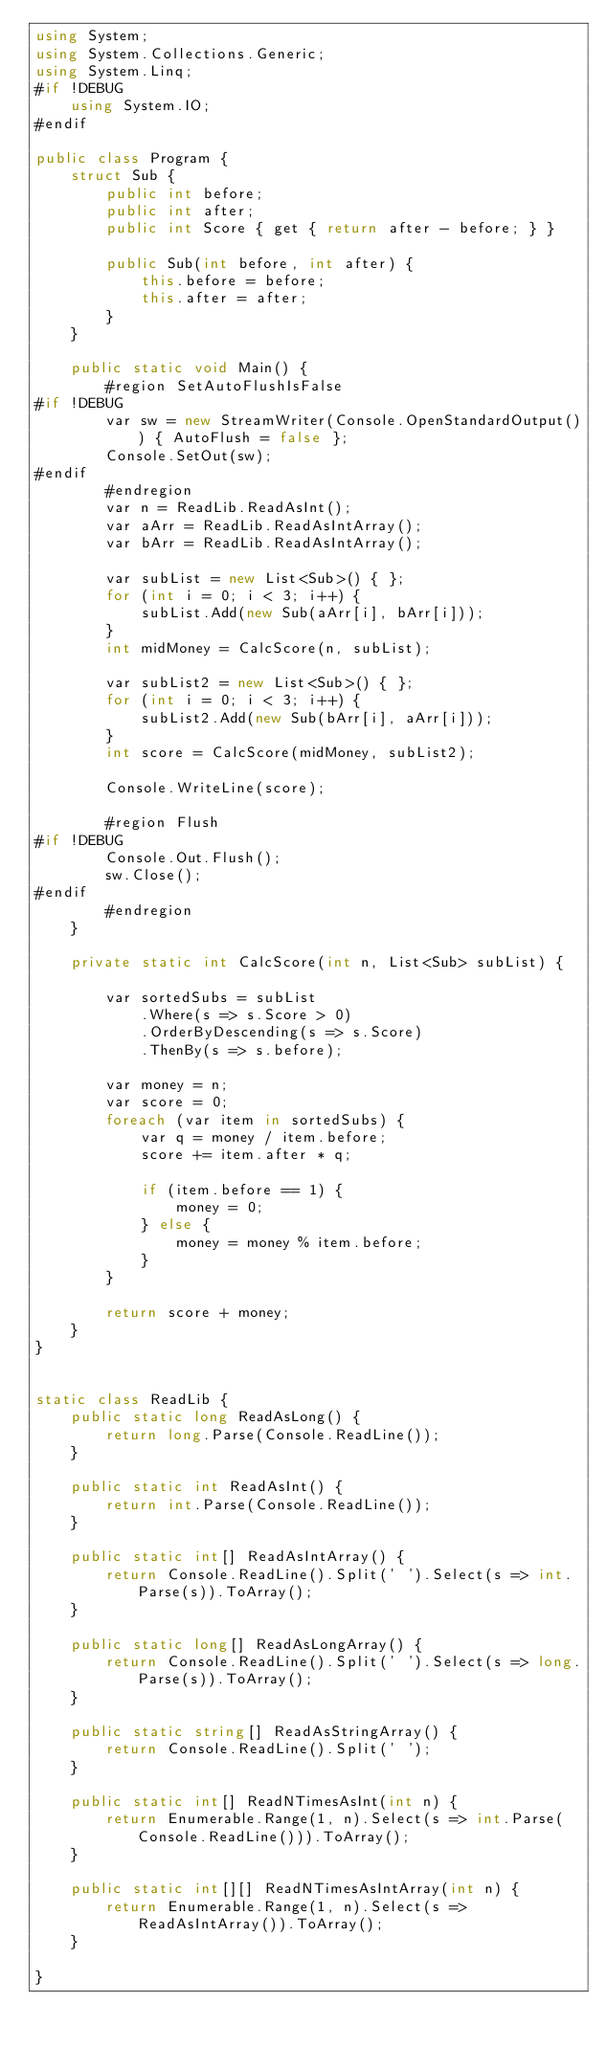<code> <loc_0><loc_0><loc_500><loc_500><_C#_>using System;
using System.Collections.Generic;
using System.Linq;
#if !DEBUG
    using System.IO;
#endif

public class Program {
    struct Sub {
        public int before;
        public int after;
        public int Score { get { return after - before; } }

        public Sub(int before, int after) {
            this.before = before;
            this.after = after;
        }
    }

    public static void Main() {
        #region SetAutoFlushIsFalse
#if !DEBUG
        var sw = new StreamWriter(Console.OpenStandardOutput()) { AutoFlush = false };
        Console.SetOut(sw);
#endif
        #endregion
        var n = ReadLib.ReadAsInt();
        var aArr = ReadLib.ReadAsIntArray();
        var bArr = ReadLib.ReadAsIntArray();

        var subList = new List<Sub>() { };
        for (int i = 0; i < 3; i++) {
            subList.Add(new Sub(aArr[i], bArr[i]));
        }
        int midMoney = CalcScore(n, subList);

        var subList2 = new List<Sub>() { };
        for (int i = 0; i < 3; i++) {
            subList2.Add(new Sub(bArr[i], aArr[i]));
        }
        int score = CalcScore(midMoney, subList2);

        Console.WriteLine(score);

        #region Flush
#if !DEBUG
        Console.Out.Flush();
        sw.Close();
#endif
        #endregion
    }

    private static int CalcScore(int n, List<Sub> subList) {

        var sortedSubs = subList
            .Where(s => s.Score > 0)
            .OrderByDescending(s => s.Score)
            .ThenBy(s => s.before);

        var money = n;
        var score = 0;
        foreach (var item in sortedSubs) {
            var q = money / item.before;
            score += item.after * q;

            if (item.before == 1) {
                money = 0;
            } else {
                money = money % item.before;
            }
        }

        return score + money;
    }
}


static class ReadLib {
    public static long ReadAsLong() {
        return long.Parse(Console.ReadLine());
    }

    public static int ReadAsInt() {
        return int.Parse(Console.ReadLine());
    }

    public static int[] ReadAsIntArray() {
        return Console.ReadLine().Split(' ').Select(s => int.Parse(s)).ToArray();
    }

    public static long[] ReadAsLongArray() {
        return Console.ReadLine().Split(' ').Select(s => long.Parse(s)).ToArray();
    }

    public static string[] ReadAsStringArray() {
        return Console.ReadLine().Split(' ');
    }

    public static int[] ReadNTimesAsInt(int n) {
        return Enumerable.Range(1, n).Select(s => int.Parse(Console.ReadLine())).ToArray();
    }

    public static int[][] ReadNTimesAsIntArray(int n) {
        return Enumerable.Range(1, n).Select(s => ReadAsIntArray()).ToArray();
    }

}</code> 